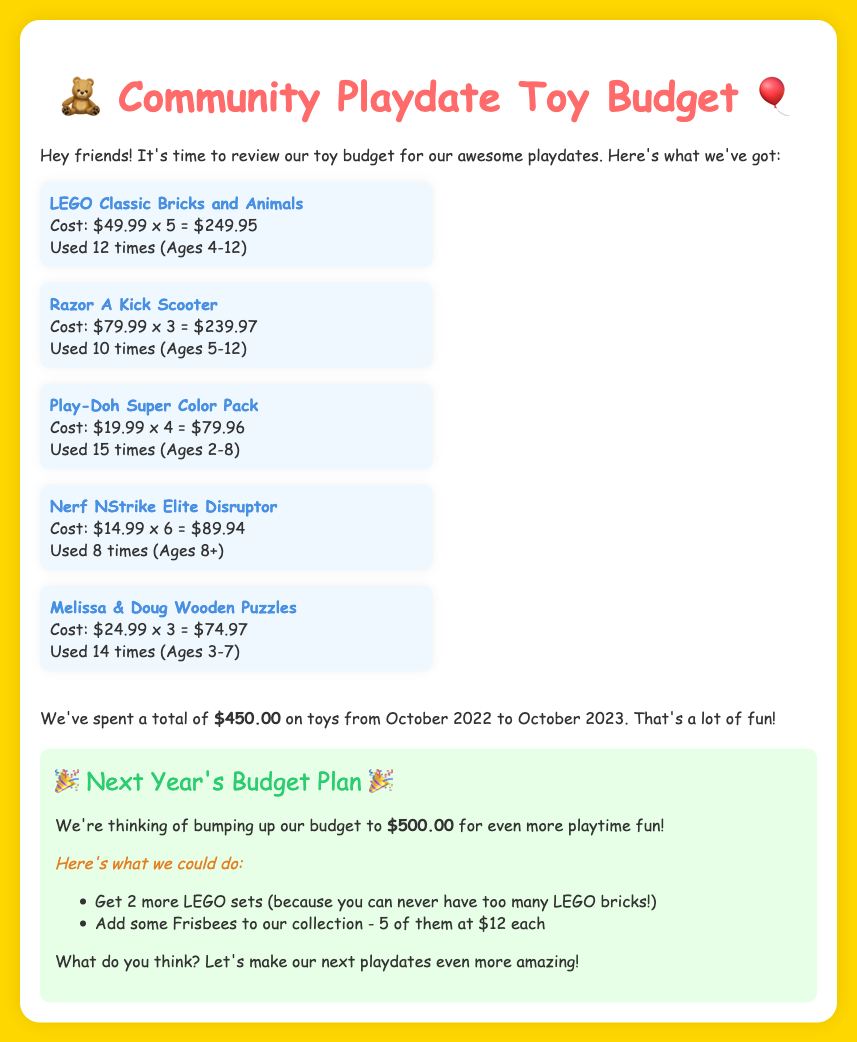What is the total cost spent on toys? The total cost is clearly stated in the document as the sum of all toy purchases, which is $450.00.
Answer: $450.00 How many times was the LEGO set used? The document mentions that the LEGO set was used 12 times during community playdates.
Answer: 12 times What is the cost of one Razor A Kick Scooter? The cost per Razor A Kick Scooter is specified in the document as $79.99.
Answer: $79.99 How many LEGO sets are planned for next year's budget? The document indicates a plan to get 2 more LEGO sets for the upcoming budget.
Answer: 2 LEGO sets What age range is the Play-Doh Super Color Pack suitable for? The document states that the Play-Doh Super Color Pack is suitable for ages 2-8.
Answer: Ages 2-8 How many times was the Nerf NStrike Elite Disruptor used? The document states that the Nerf NStrike Elite Disruptor was used 8 times.
Answer: 8 times What is the proposed budget for next year? The document proposes a budget of $500.00 for the next year's playdates.
Answer: $500.00 How many Melissa & Doug Wooden Puzzles were purchased? The document specifies that 3 Melissa & Doug Wooden Puzzles were purchased.
Answer: 3 Wooden Puzzles What toy type is not recommended for ages under 8? The document indicates that the Nerf NStrike Elite Disruptor is suitable for ages 8 and above, making it unsuitable for younger children.
Answer: Nerf NStrike Elite Disruptor 